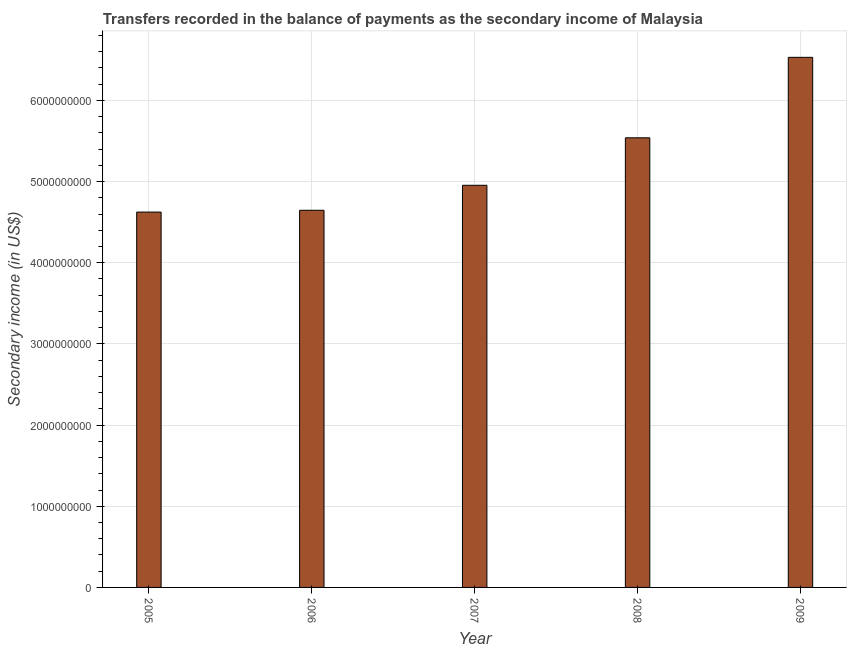What is the title of the graph?
Ensure brevity in your answer.  Transfers recorded in the balance of payments as the secondary income of Malaysia. What is the label or title of the Y-axis?
Provide a short and direct response. Secondary income (in US$). What is the amount of secondary income in 2005?
Make the answer very short. 4.62e+09. Across all years, what is the maximum amount of secondary income?
Your response must be concise. 6.53e+09. Across all years, what is the minimum amount of secondary income?
Provide a short and direct response. 4.62e+09. In which year was the amount of secondary income maximum?
Provide a short and direct response. 2009. What is the sum of the amount of secondary income?
Provide a short and direct response. 2.63e+1. What is the difference between the amount of secondary income in 2007 and 2008?
Ensure brevity in your answer.  -5.85e+08. What is the average amount of secondary income per year?
Give a very brief answer. 5.26e+09. What is the median amount of secondary income?
Your answer should be very brief. 4.95e+09. What is the ratio of the amount of secondary income in 2006 to that in 2009?
Provide a short and direct response. 0.71. Is the amount of secondary income in 2005 less than that in 2008?
Your answer should be very brief. Yes. What is the difference between the highest and the second highest amount of secondary income?
Offer a terse response. 9.91e+08. What is the difference between the highest and the lowest amount of secondary income?
Keep it short and to the point. 1.91e+09. How many bars are there?
Offer a very short reply. 5. Are all the bars in the graph horizontal?
Give a very brief answer. No. What is the Secondary income (in US$) of 2005?
Give a very brief answer. 4.62e+09. What is the Secondary income (in US$) in 2006?
Provide a succinct answer. 4.65e+09. What is the Secondary income (in US$) of 2007?
Keep it short and to the point. 4.95e+09. What is the Secondary income (in US$) in 2008?
Your response must be concise. 5.54e+09. What is the Secondary income (in US$) in 2009?
Make the answer very short. 6.53e+09. What is the difference between the Secondary income (in US$) in 2005 and 2006?
Your answer should be very brief. -2.22e+07. What is the difference between the Secondary income (in US$) in 2005 and 2007?
Your answer should be very brief. -3.30e+08. What is the difference between the Secondary income (in US$) in 2005 and 2008?
Provide a short and direct response. -9.15e+08. What is the difference between the Secondary income (in US$) in 2005 and 2009?
Make the answer very short. -1.91e+09. What is the difference between the Secondary income (in US$) in 2006 and 2007?
Offer a terse response. -3.08e+08. What is the difference between the Secondary income (in US$) in 2006 and 2008?
Offer a terse response. -8.93e+08. What is the difference between the Secondary income (in US$) in 2006 and 2009?
Provide a succinct answer. -1.88e+09. What is the difference between the Secondary income (in US$) in 2007 and 2008?
Your answer should be very brief. -5.85e+08. What is the difference between the Secondary income (in US$) in 2007 and 2009?
Your answer should be compact. -1.58e+09. What is the difference between the Secondary income (in US$) in 2008 and 2009?
Give a very brief answer. -9.91e+08. What is the ratio of the Secondary income (in US$) in 2005 to that in 2006?
Offer a terse response. 0.99. What is the ratio of the Secondary income (in US$) in 2005 to that in 2007?
Provide a succinct answer. 0.93. What is the ratio of the Secondary income (in US$) in 2005 to that in 2008?
Offer a terse response. 0.83. What is the ratio of the Secondary income (in US$) in 2005 to that in 2009?
Your response must be concise. 0.71. What is the ratio of the Secondary income (in US$) in 2006 to that in 2007?
Make the answer very short. 0.94. What is the ratio of the Secondary income (in US$) in 2006 to that in 2008?
Provide a succinct answer. 0.84. What is the ratio of the Secondary income (in US$) in 2006 to that in 2009?
Keep it short and to the point. 0.71. What is the ratio of the Secondary income (in US$) in 2007 to that in 2008?
Give a very brief answer. 0.89. What is the ratio of the Secondary income (in US$) in 2007 to that in 2009?
Your answer should be very brief. 0.76. What is the ratio of the Secondary income (in US$) in 2008 to that in 2009?
Your response must be concise. 0.85. 